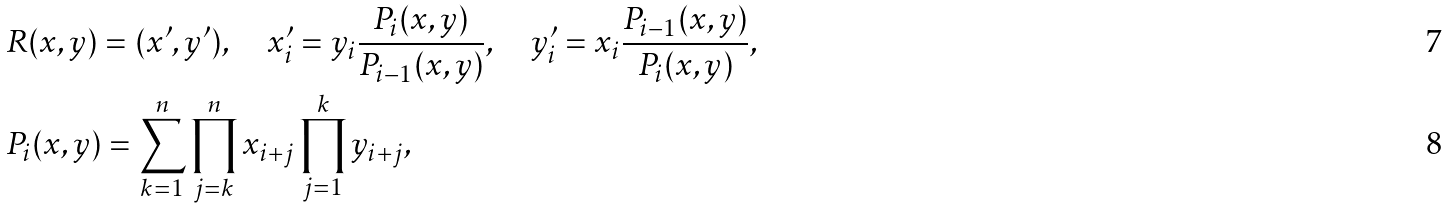Convert formula to latex. <formula><loc_0><loc_0><loc_500><loc_500>& R ( x , y ) = ( x ^ { \prime } , y ^ { \prime } ) , \quad x ^ { \prime } _ { i } = y _ { i } \frac { P _ { i } ( x , y ) } { P _ { i - 1 } ( x , y ) } , \quad y ^ { \prime } _ { i } = x _ { i } \frac { P _ { i - 1 } ( x , y ) } { P _ { i } ( x , y ) } , \\ & P _ { i } ( x , y ) = \sum _ { k = 1 } ^ { n } \prod _ { j = k } ^ { n } x _ { i + j } \prod _ { j = 1 } ^ { k } y _ { i + j } ,</formula> 